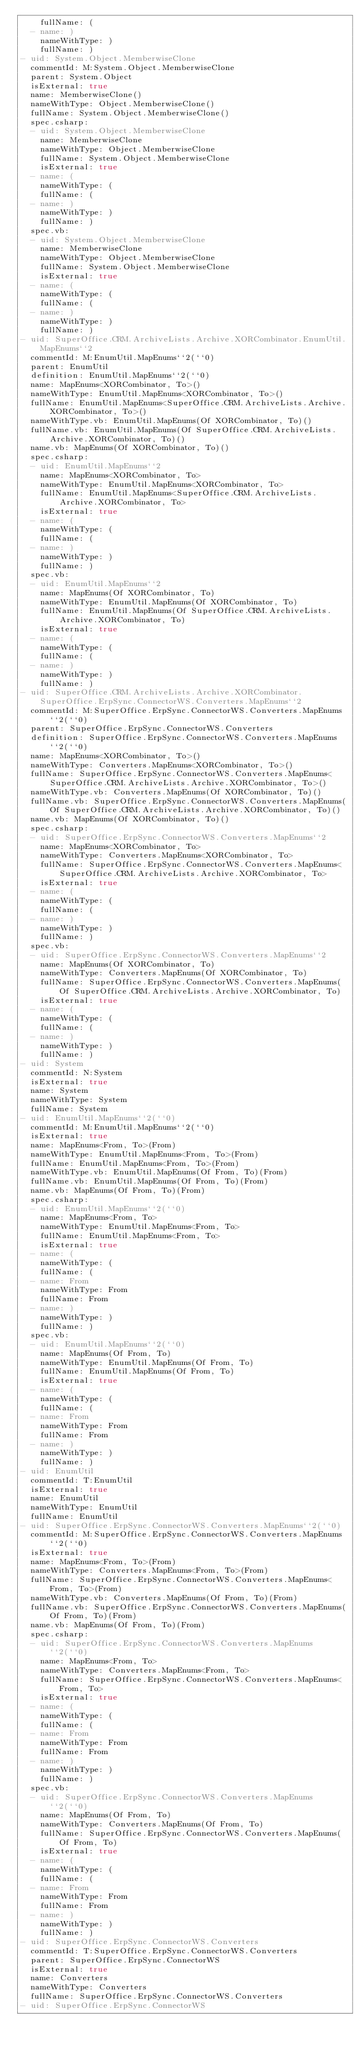<code> <loc_0><loc_0><loc_500><loc_500><_YAML_>    fullName: (
  - name: )
    nameWithType: )
    fullName: )
- uid: System.Object.MemberwiseClone
  commentId: M:System.Object.MemberwiseClone
  parent: System.Object
  isExternal: true
  name: MemberwiseClone()
  nameWithType: Object.MemberwiseClone()
  fullName: System.Object.MemberwiseClone()
  spec.csharp:
  - uid: System.Object.MemberwiseClone
    name: MemberwiseClone
    nameWithType: Object.MemberwiseClone
    fullName: System.Object.MemberwiseClone
    isExternal: true
  - name: (
    nameWithType: (
    fullName: (
  - name: )
    nameWithType: )
    fullName: )
  spec.vb:
  - uid: System.Object.MemberwiseClone
    name: MemberwiseClone
    nameWithType: Object.MemberwiseClone
    fullName: System.Object.MemberwiseClone
    isExternal: true
  - name: (
    nameWithType: (
    fullName: (
  - name: )
    nameWithType: )
    fullName: )
- uid: SuperOffice.CRM.ArchiveLists.Archive.XORCombinator.EnumUtil.MapEnums``2
  commentId: M:EnumUtil.MapEnums``2(``0)
  parent: EnumUtil
  definition: EnumUtil.MapEnums``2(``0)
  name: MapEnums<XORCombinator, To>()
  nameWithType: EnumUtil.MapEnums<XORCombinator, To>()
  fullName: EnumUtil.MapEnums<SuperOffice.CRM.ArchiveLists.Archive.XORCombinator, To>()
  nameWithType.vb: EnumUtil.MapEnums(Of XORCombinator, To)()
  fullName.vb: EnumUtil.MapEnums(Of SuperOffice.CRM.ArchiveLists.Archive.XORCombinator, To)()
  name.vb: MapEnums(Of XORCombinator, To)()
  spec.csharp:
  - uid: EnumUtil.MapEnums``2
    name: MapEnums<XORCombinator, To>
    nameWithType: EnumUtil.MapEnums<XORCombinator, To>
    fullName: EnumUtil.MapEnums<SuperOffice.CRM.ArchiveLists.Archive.XORCombinator, To>
    isExternal: true
  - name: (
    nameWithType: (
    fullName: (
  - name: )
    nameWithType: )
    fullName: )
  spec.vb:
  - uid: EnumUtil.MapEnums``2
    name: MapEnums(Of XORCombinator, To)
    nameWithType: EnumUtil.MapEnums(Of XORCombinator, To)
    fullName: EnumUtil.MapEnums(Of SuperOffice.CRM.ArchiveLists.Archive.XORCombinator, To)
    isExternal: true
  - name: (
    nameWithType: (
    fullName: (
  - name: )
    nameWithType: )
    fullName: )
- uid: SuperOffice.CRM.ArchiveLists.Archive.XORCombinator.SuperOffice.ErpSync.ConnectorWS.Converters.MapEnums``2
  commentId: M:SuperOffice.ErpSync.ConnectorWS.Converters.MapEnums``2(``0)
  parent: SuperOffice.ErpSync.ConnectorWS.Converters
  definition: SuperOffice.ErpSync.ConnectorWS.Converters.MapEnums``2(``0)
  name: MapEnums<XORCombinator, To>()
  nameWithType: Converters.MapEnums<XORCombinator, To>()
  fullName: SuperOffice.ErpSync.ConnectorWS.Converters.MapEnums<SuperOffice.CRM.ArchiveLists.Archive.XORCombinator, To>()
  nameWithType.vb: Converters.MapEnums(Of XORCombinator, To)()
  fullName.vb: SuperOffice.ErpSync.ConnectorWS.Converters.MapEnums(Of SuperOffice.CRM.ArchiveLists.Archive.XORCombinator, To)()
  name.vb: MapEnums(Of XORCombinator, To)()
  spec.csharp:
  - uid: SuperOffice.ErpSync.ConnectorWS.Converters.MapEnums``2
    name: MapEnums<XORCombinator, To>
    nameWithType: Converters.MapEnums<XORCombinator, To>
    fullName: SuperOffice.ErpSync.ConnectorWS.Converters.MapEnums<SuperOffice.CRM.ArchiveLists.Archive.XORCombinator, To>
    isExternal: true
  - name: (
    nameWithType: (
    fullName: (
  - name: )
    nameWithType: )
    fullName: )
  spec.vb:
  - uid: SuperOffice.ErpSync.ConnectorWS.Converters.MapEnums``2
    name: MapEnums(Of XORCombinator, To)
    nameWithType: Converters.MapEnums(Of XORCombinator, To)
    fullName: SuperOffice.ErpSync.ConnectorWS.Converters.MapEnums(Of SuperOffice.CRM.ArchiveLists.Archive.XORCombinator, To)
    isExternal: true
  - name: (
    nameWithType: (
    fullName: (
  - name: )
    nameWithType: )
    fullName: )
- uid: System
  commentId: N:System
  isExternal: true
  name: System
  nameWithType: System
  fullName: System
- uid: EnumUtil.MapEnums``2(``0)
  commentId: M:EnumUtil.MapEnums``2(``0)
  isExternal: true
  name: MapEnums<From, To>(From)
  nameWithType: EnumUtil.MapEnums<From, To>(From)
  fullName: EnumUtil.MapEnums<From, To>(From)
  nameWithType.vb: EnumUtil.MapEnums(Of From, To)(From)
  fullName.vb: EnumUtil.MapEnums(Of From, To)(From)
  name.vb: MapEnums(Of From, To)(From)
  spec.csharp:
  - uid: EnumUtil.MapEnums``2(``0)
    name: MapEnums<From, To>
    nameWithType: EnumUtil.MapEnums<From, To>
    fullName: EnumUtil.MapEnums<From, To>
    isExternal: true
  - name: (
    nameWithType: (
    fullName: (
  - name: From
    nameWithType: From
    fullName: From
  - name: )
    nameWithType: )
    fullName: )
  spec.vb:
  - uid: EnumUtil.MapEnums``2(``0)
    name: MapEnums(Of From, To)
    nameWithType: EnumUtil.MapEnums(Of From, To)
    fullName: EnumUtil.MapEnums(Of From, To)
    isExternal: true
  - name: (
    nameWithType: (
    fullName: (
  - name: From
    nameWithType: From
    fullName: From
  - name: )
    nameWithType: )
    fullName: )
- uid: EnumUtil
  commentId: T:EnumUtil
  isExternal: true
  name: EnumUtil
  nameWithType: EnumUtil
  fullName: EnumUtil
- uid: SuperOffice.ErpSync.ConnectorWS.Converters.MapEnums``2(``0)
  commentId: M:SuperOffice.ErpSync.ConnectorWS.Converters.MapEnums``2(``0)
  isExternal: true
  name: MapEnums<From, To>(From)
  nameWithType: Converters.MapEnums<From, To>(From)
  fullName: SuperOffice.ErpSync.ConnectorWS.Converters.MapEnums<From, To>(From)
  nameWithType.vb: Converters.MapEnums(Of From, To)(From)
  fullName.vb: SuperOffice.ErpSync.ConnectorWS.Converters.MapEnums(Of From, To)(From)
  name.vb: MapEnums(Of From, To)(From)
  spec.csharp:
  - uid: SuperOffice.ErpSync.ConnectorWS.Converters.MapEnums``2(``0)
    name: MapEnums<From, To>
    nameWithType: Converters.MapEnums<From, To>
    fullName: SuperOffice.ErpSync.ConnectorWS.Converters.MapEnums<From, To>
    isExternal: true
  - name: (
    nameWithType: (
    fullName: (
  - name: From
    nameWithType: From
    fullName: From
  - name: )
    nameWithType: )
    fullName: )
  spec.vb:
  - uid: SuperOffice.ErpSync.ConnectorWS.Converters.MapEnums``2(``0)
    name: MapEnums(Of From, To)
    nameWithType: Converters.MapEnums(Of From, To)
    fullName: SuperOffice.ErpSync.ConnectorWS.Converters.MapEnums(Of From, To)
    isExternal: true
  - name: (
    nameWithType: (
    fullName: (
  - name: From
    nameWithType: From
    fullName: From
  - name: )
    nameWithType: )
    fullName: )
- uid: SuperOffice.ErpSync.ConnectorWS.Converters
  commentId: T:SuperOffice.ErpSync.ConnectorWS.Converters
  parent: SuperOffice.ErpSync.ConnectorWS
  isExternal: true
  name: Converters
  nameWithType: Converters
  fullName: SuperOffice.ErpSync.ConnectorWS.Converters
- uid: SuperOffice.ErpSync.ConnectorWS</code> 